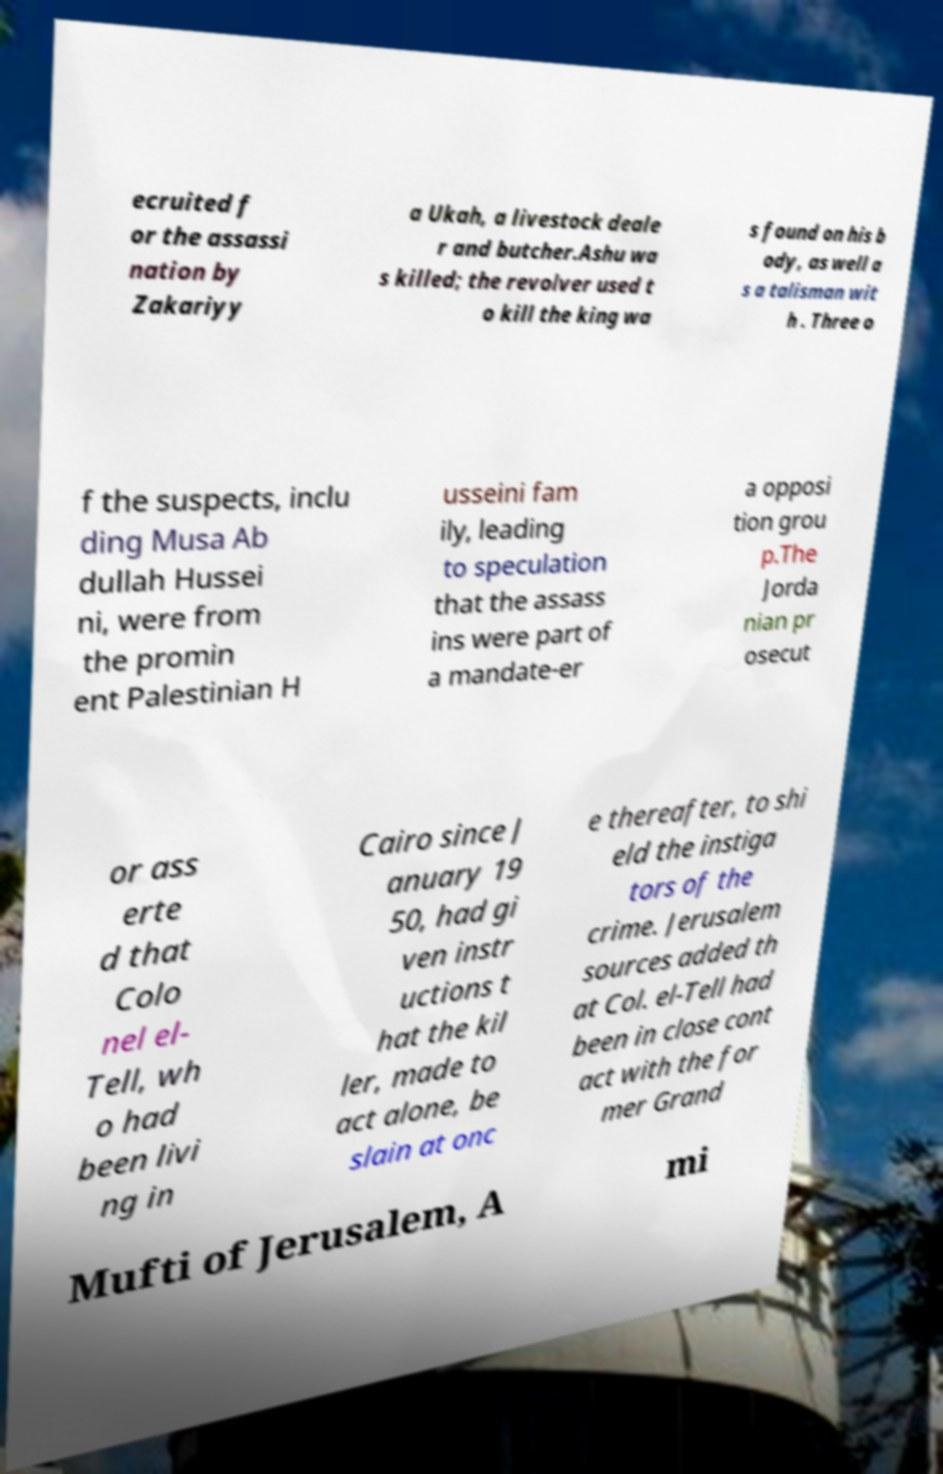Can you read and provide the text displayed in the image?This photo seems to have some interesting text. Can you extract and type it out for me? ecruited f or the assassi nation by Zakariyy a Ukah, a livestock deale r and butcher.Ashu wa s killed; the revolver used t o kill the king wa s found on his b ody, as well a s a talisman wit h . Three o f the suspects, inclu ding Musa Ab dullah Hussei ni, were from the promin ent Palestinian H usseini fam ily, leading to speculation that the assass ins were part of a mandate-er a opposi tion grou p.The Jorda nian pr osecut or ass erte d that Colo nel el- Tell, wh o had been livi ng in Cairo since J anuary 19 50, had gi ven instr uctions t hat the kil ler, made to act alone, be slain at onc e thereafter, to shi eld the instiga tors of the crime. Jerusalem sources added th at Col. el-Tell had been in close cont act with the for mer Grand Mufti of Jerusalem, A mi 